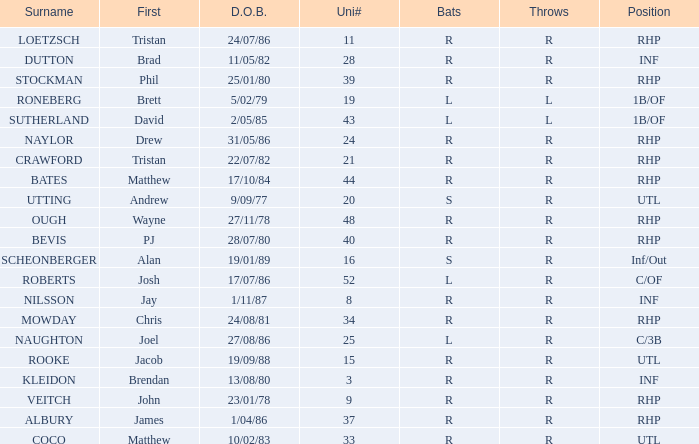How many Uni numbers have Bats of s, and a Position of utl? 1.0. 